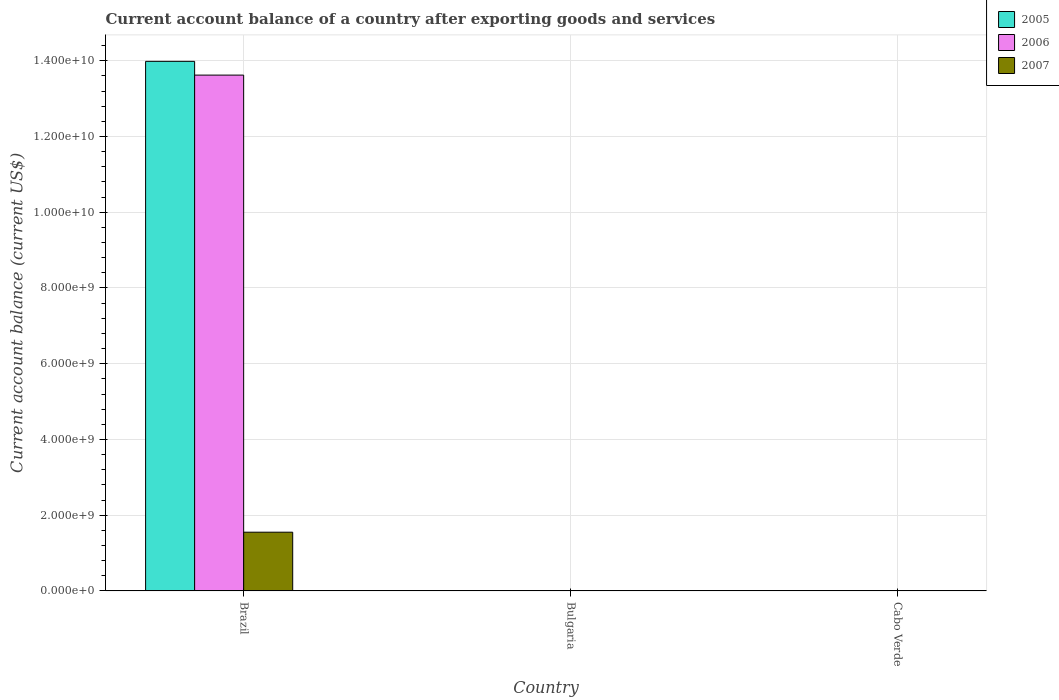How many different coloured bars are there?
Keep it short and to the point. 3. Are the number of bars per tick equal to the number of legend labels?
Ensure brevity in your answer.  No. Are the number of bars on each tick of the X-axis equal?
Offer a very short reply. No. How many bars are there on the 2nd tick from the left?
Give a very brief answer. 0. How many bars are there on the 3rd tick from the right?
Ensure brevity in your answer.  3. What is the label of the 3rd group of bars from the left?
Offer a very short reply. Cabo Verde. In how many cases, is the number of bars for a given country not equal to the number of legend labels?
Keep it short and to the point. 2. What is the account balance in 2006 in Bulgaria?
Give a very brief answer. 0. Across all countries, what is the maximum account balance in 2005?
Offer a very short reply. 1.40e+1. Across all countries, what is the minimum account balance in 2007?
Offer a very short reply. 0. What is the total account balance in 2006 in the graph?
Give a very brief answer. 1.36e+1. What is the difference between the account balance in 2005 in Brazil and the account balance in 2006 in Bulgaria?
Your answer should be very brief. 1.40e+1. What is the average account balance in 2005 per country?
Ensure brevity in your answer.  4.66e+09. What is the difference between the account balance of/in 2006 and account balance of/in 2005 in Brazil?
Keep it short and to the point. -3.63e+08. What is the difference between the highest and the lowest account balance in 2007?
Ensure brevity in your answer.  1.55e+09. What is the difference between two consecutive major ticks on the Y-axis?
Offer a very short reply. 2.00e+09. Are the values on the major ticks of Y-axis written in scientific E-notation?
Provide a succinct answer. Yes. Does the graph contain any zero values?
Your answer should be compact. Yes. What is the title of the graph?
Your response must be concise. Current account balance of a country after exporting goods and services. Does "1978" appear as one of the legend labels in the graph?
Keep it short and to the point. No. What is the label or title of the Y-axis?
Provide a succinct answer. Current account balance (current US$). What is the Current account balance (current US$) of 2005 in Brazil?
Offer a very short reply. 1.40e+1. What is the Current account balance (current US$) of 2006 in Brazil?
Your answer should be compact. 1.36e+1. What is the Current account balance (current US$) of 2007 in Brazil?
Offer a very short reply. 1.55e+09. Across all countries, what is the maximum Current account balance (current US$) in 2005?
Keep it short and to the point. 1.40e+1. Across all countries, what is the maximum Current account balance (current US$) in 2006?
Offer a very short reply. 1.36e+1. Across all countries, what is the maximum Current account balance (current US$) of 2007?
Your response must be concise. 1.55e+09. Across all countries, what is the minimum Current account balance (current US$) in 2006?
Your answer should be compact. 0. Across all countries, what is the minimum Current account balance (current US$) in 2007?
Your answer should be compact. 0. What is the total Current account balance (current US$) in 2005 in the graph?
Provide a succinct answer. 1.40e+1. What is the total Current account balance (current US$) in 2006 in the graph?
Your response must be concise. 1.36e+1. What is the total Current account balance (current US$) of 2007 in the graph?
Give a very brief answer. 1.55e+09. What is the average Current account balance (current US$) in 2005 per country?
Ensure brevity in your answer.  4.66e+09. What is the average Current account balance (current US$) of 2006 per country?
Provide a succinct answer. 4.54e+09. What is the average Current account balance (current US$) of 2007 per country?
Offer a terse response. 5.17e+08. What is the difference between the Current account balance (current US$) in 2005 and Current account balance (current US$) in 2006 in Brazil?
Your answer should be very brief. 3.63e+08. What is the difference between the Current account balance (current US$) in 2005 and Current account balance (current US$) in 2007 in Brazil?
Your answer should be very brief. 1.24e+1. What is the difference between the Current account balance (current US$) in 2006 and Current account balance (current US$) in 2007 in Brazil?
Make the answer very short. 1.21e+1. What is the difference between the highest and the lowest Current account balance (current US$) in 2005?
Your answer should be very brief. 1.40e+1. What is the difference between the highest and the lowest Current account balance (current US$) in 2006?
Your answer should be very brief. 1.36e+1. What is the difference between the highest and the lowest Current account balance (current US$) in 2007?
Keep it short and to the point. 1.55e+09. 